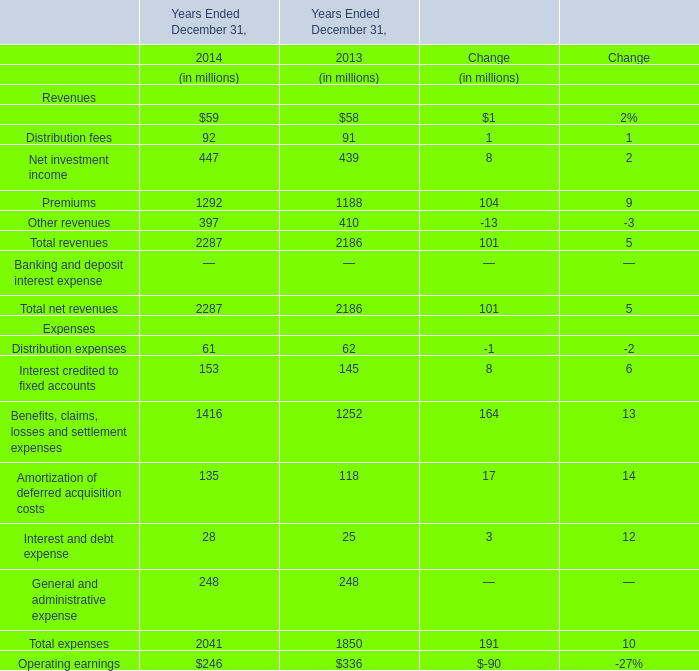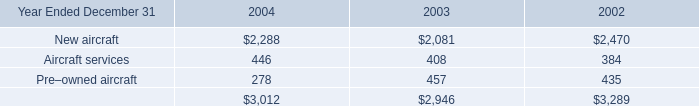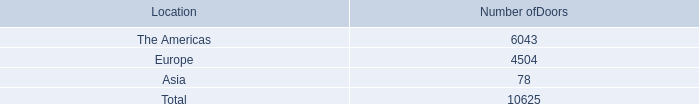What's the average of Management and financial advice fees and Distribution fees in 2014? (in dollars in millions) 
Computations: ((59 + 92) / 2)
Answer: 75.5. 